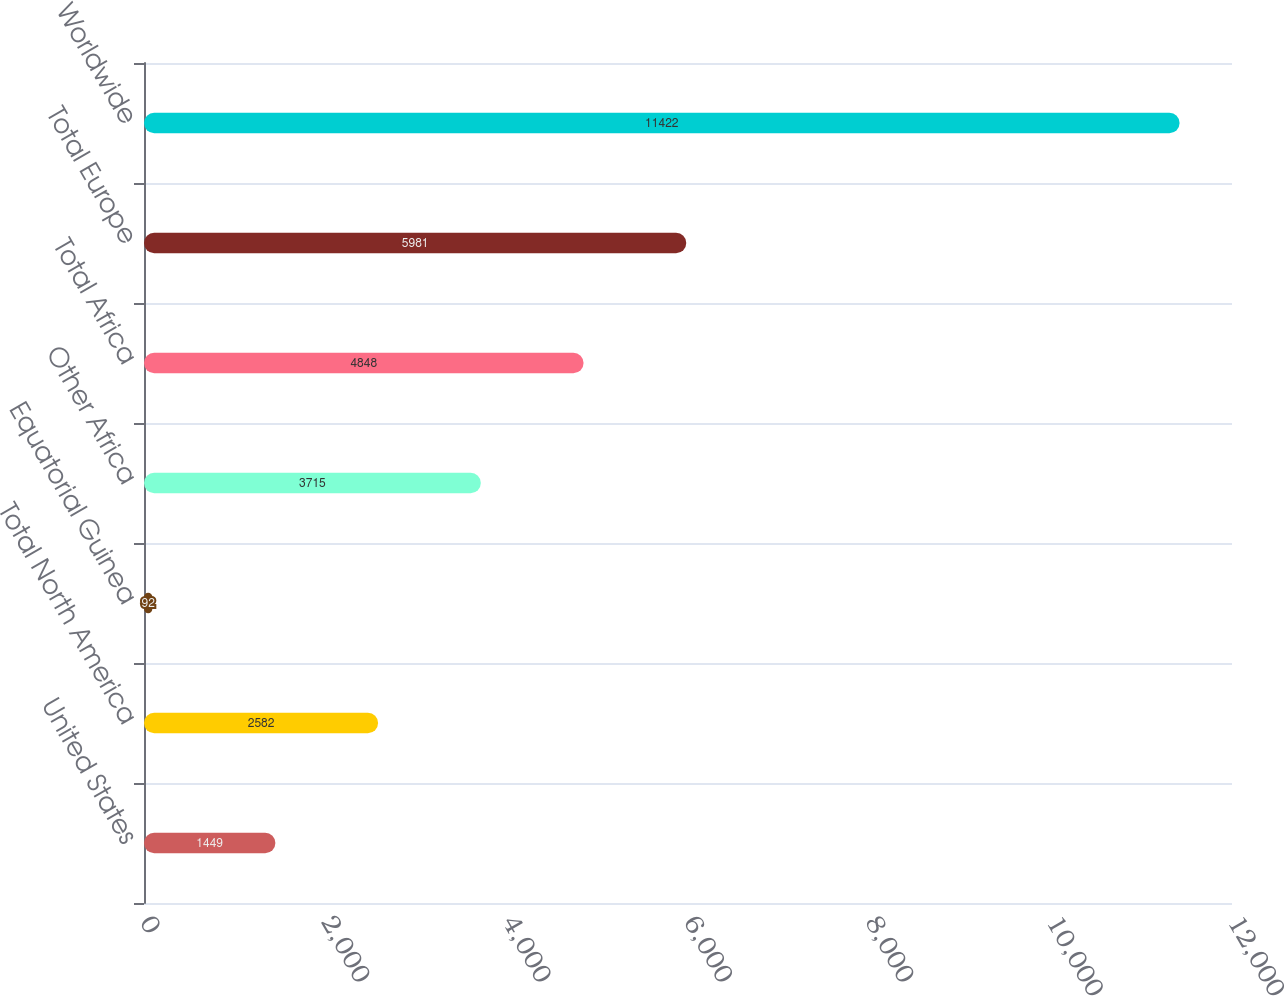Convert chart. <chart><loc_0><loc_0><loc_500><loc_500><bar_chart><fcel>United States<fcel>Total North America<fcel>Equatorial Guinea<fcel>Other Africa<fcel>Total Africa<fcel>Total Europe<fcel>Worldwide<nl><fcel>1449<fcel>2582<fcel>92<fcel>3715<fcel>4848<fcel>5981<fcel>11422<nl></chart> 